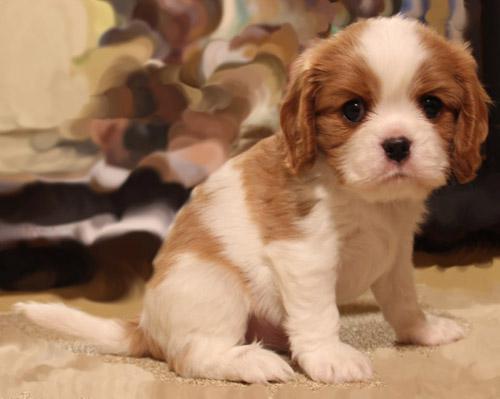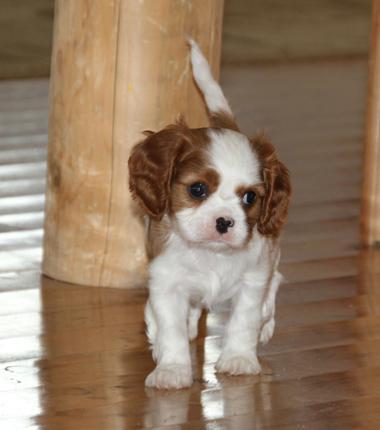The first image is the image on the left, the second image is the image on the right. Considering the images on both sides, is "In one image there is a lone Cavalier King Charles Spaniel laying down looking at the camera in the center of the image." valid? Answer yes or no. No. The first image is the image on the left, the second image is the image on the right. For the images shown, is this caption "There are a total of three animals." true? Answer yes or no. No. The first image is the image on the left, the second image is the image on the right. Evaluate the accuracy of this statement regarding the images: "There are at most two dogs.". Is it true? Answer yes or no. Yes. The first image is the image on the left, the second image is the image on the right. Given the left and right images, does the statement "One image features two animals, although one may not be a puppy, on a plain background." hold true? Answer yes or no. No. The first image is the image on the left, the second image is the image on the right. Given the left and right images, does the statement "An image shows a brown and white spaniel posed next to another animal." hold true? Answer yes or no. No. The first image is the image on the left, the second image is the image on the right. For the images displayed, is the sentence "An image shows a puppy on a tile floor." factually correct? Answer yes or no. No. The first image is the image on the left, the second image is the image on the right. Considering the images on both sides, is "the right image has a dog on a brwon floor with a tan pillar behind them" valid? Answer yes or no. Yes. The first image is the image on the left, the second image is the image on the right. Evaluate the accuracy of this statement regarding the images: "Each image has one dog.". Is it true? Answer yes or no. Yes. 